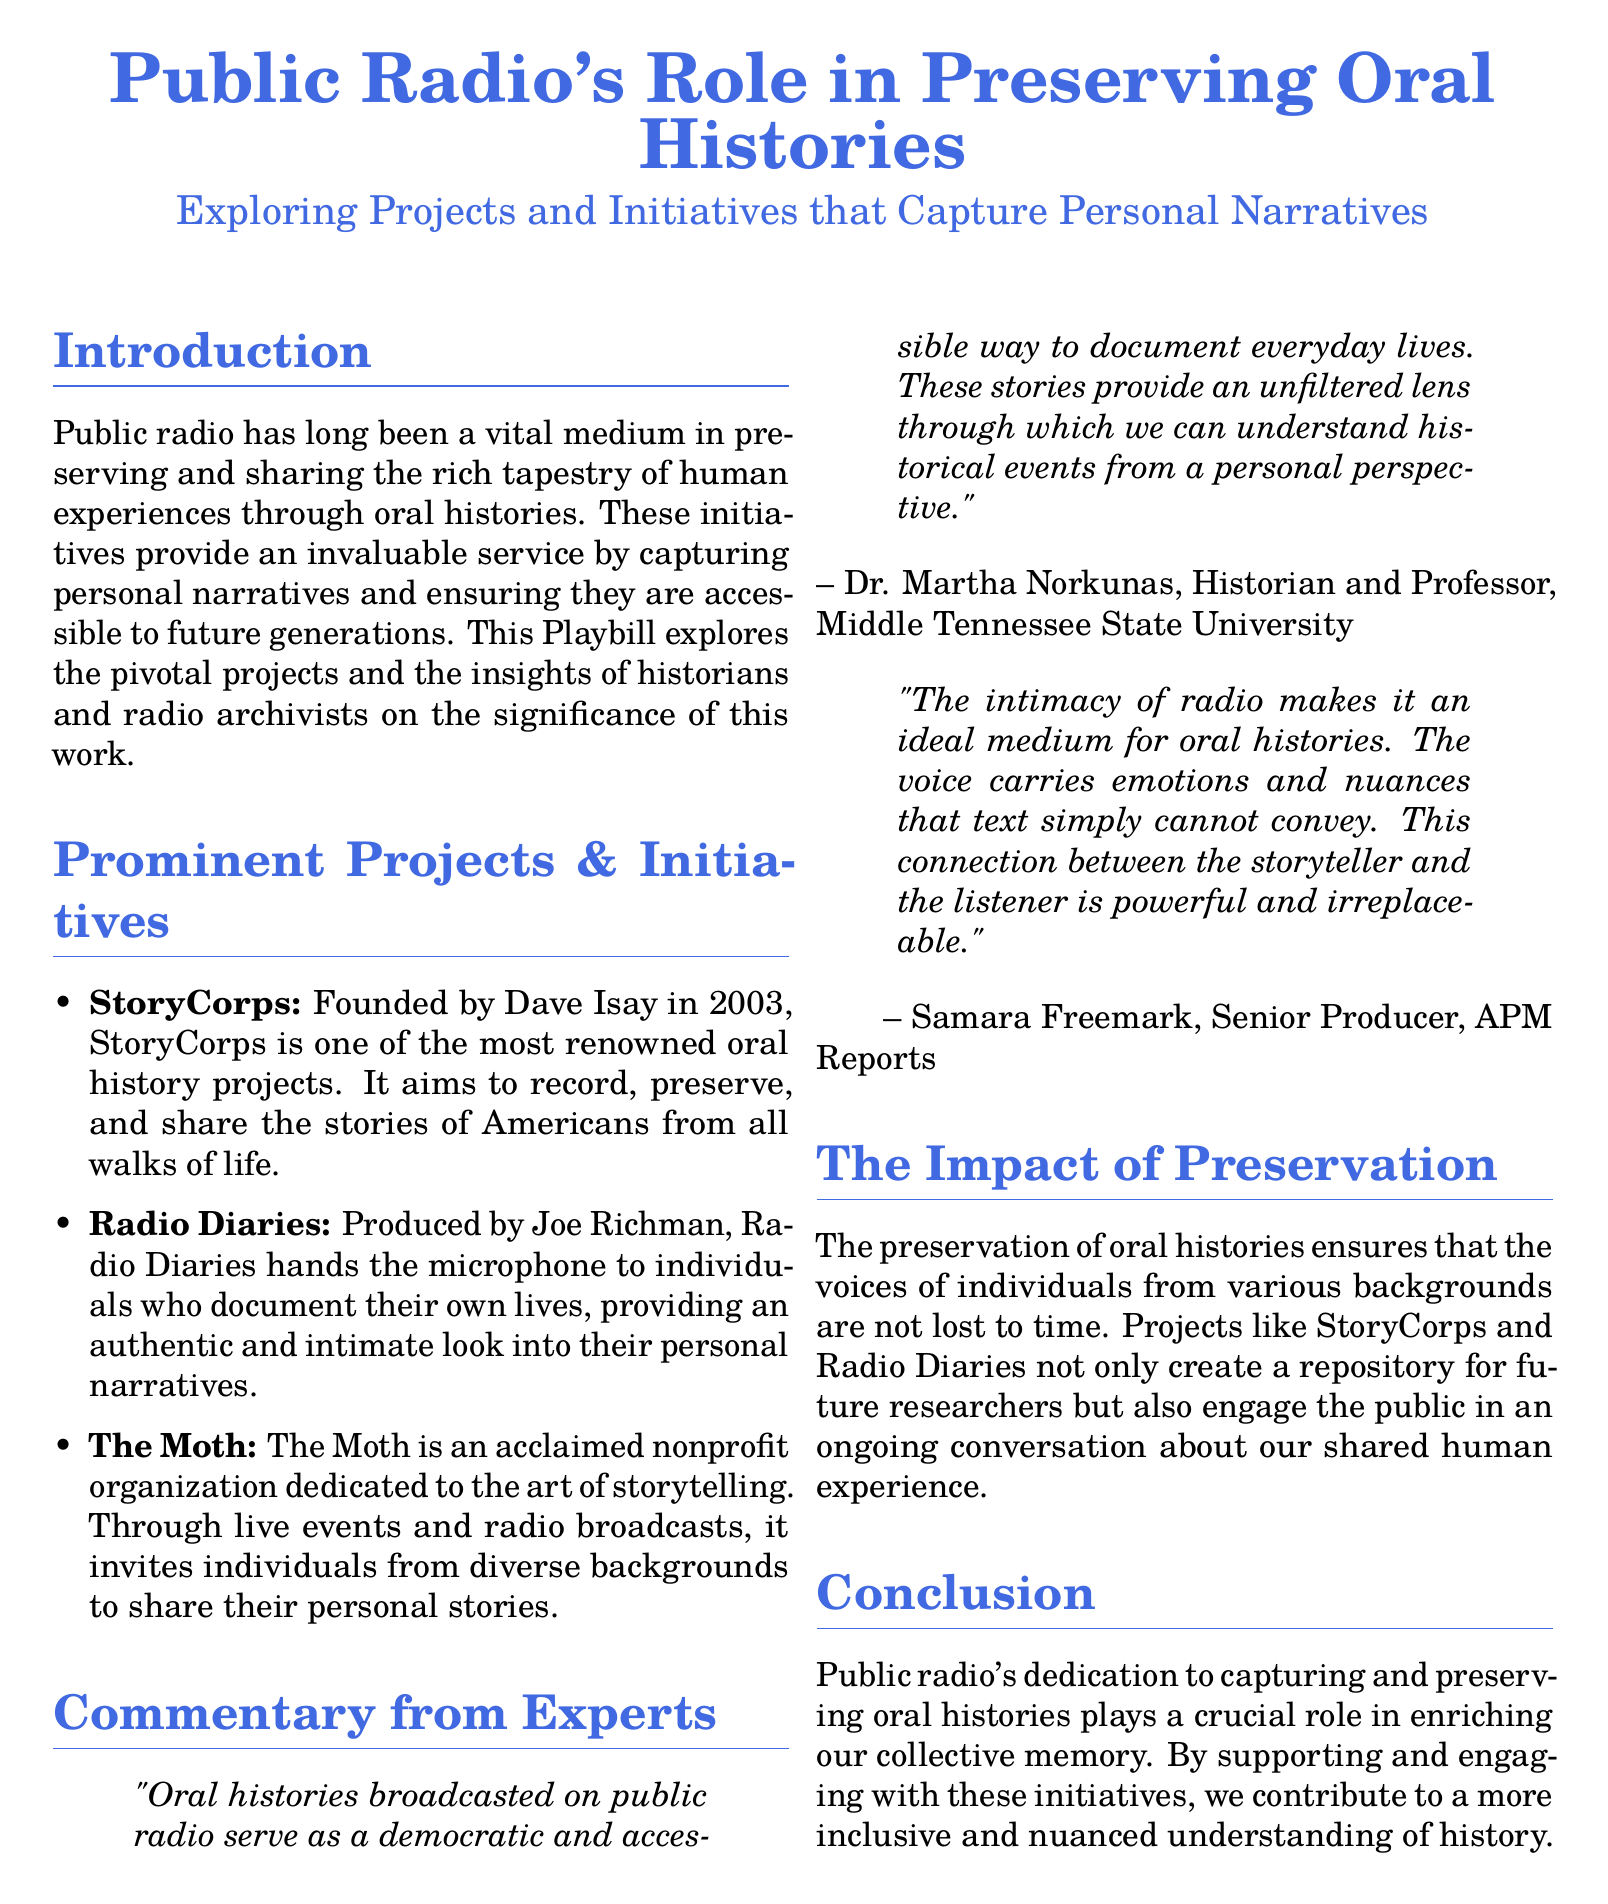What is the title of the Playbill? The title of the Playbill is presented prominently at the beginning of the document.
Answer: Public Radio's Role in Preserving Oral Histories Who founded StoryCorps? The document includes information on the founder of StoryCorps, a prominent oral history project.
Answer: Dave Isay In what year was StoryCorps founded? The document states the founding year of StoryCorps, which is provided in the description of the project.
Answer: 2003 What does Radio Diaries provide? The document mentions the focus of Radio Diaries, which highlights its unique approach to storytelling.
Answer: An authentic and intimate look into their personal narratives Who is Dr. Martha Norkunas? The document contains a quote from a historian, providing her name and role.
Answer: Historian and Professor What is the main goal of public radio initiatives discussed in the document? The document outlines the overarching aim of public radio's oral history projects.
Answer: To preserve and share the rich tapestry of human experiences What unique aspect of radio does Samara Freemark mention? The document includes a quote that emphasizes a specific characteristic of the radio medium.
Answer: Intimacy What is the conclusion about public radio's role? The document provides a definitive statement summarizing public radio's significance in the conclusion section.
Answer: Enriching our collective memory 